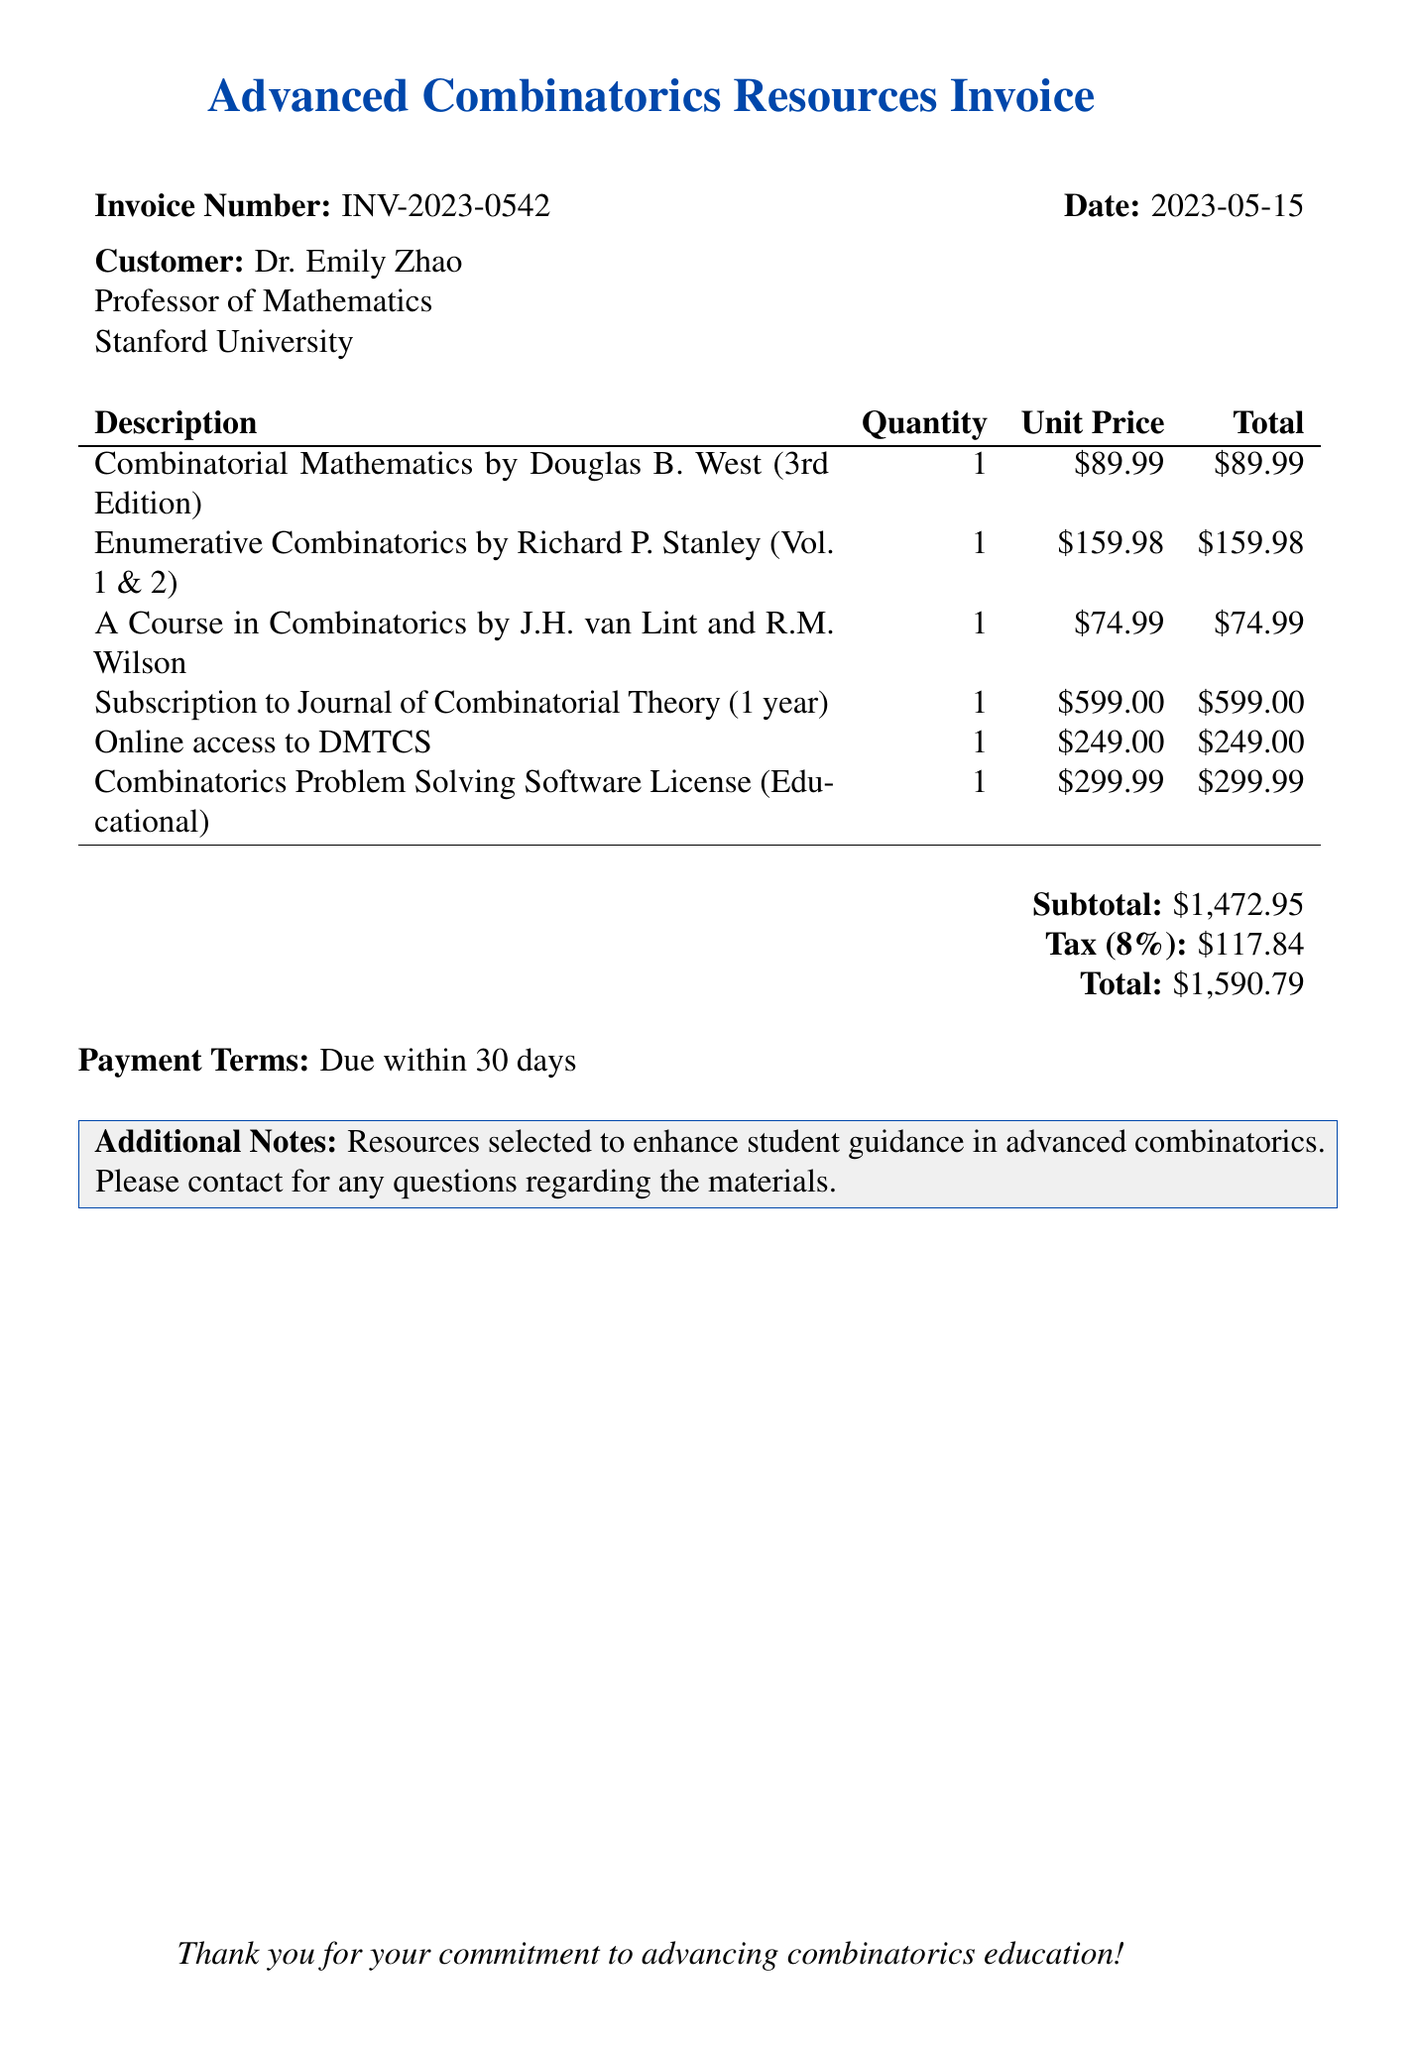what is the invoice number? The invoice number can be found at the top of the document, labeled as "Invoice Number."
Answer: INV-2023-0542 who is the customer? The customer's name is mentioned under the "Customer" section at the beginning of the document.
Answer: Dr. Emily Zhao what is the date of the invoice? The date of the invoice is specified right next to the invoice number.
Answer: 2023-05-15 what is the subtotal amount? The subtotal is displayed near the bottom of the invoice as the sum before taxes.
Answer: $1,472.95 how much is the tax? The tax amount is provided as a separate line item near the total at the bottom of the document.
Answer: $117.84 how many books were purchased? The document lists a total of three distinct books purchased under "Description."
Answer: 3 what is the total amount due? The total amount due is clearly shown at the bottom of the invoice after taxes are added.
Answer: $1,590.79 what is the duration of the subscription service? The duration for the subscription to the Journal of Combinatorial Theory is indicated in the description of the item.
Answer: 1 year what is the purpose of the additional notes section? The additional notes section provides context and purpose regarding the resources selected for guidance.
Answer: Resources selected to enhance student guidance in advanced combinatorics 